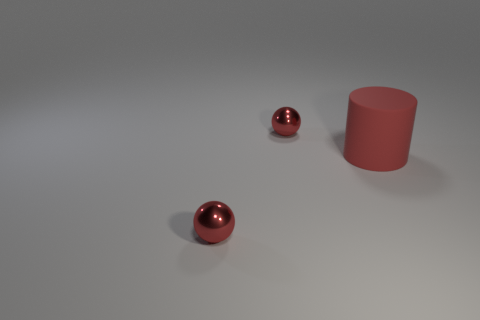How would you interpret the mood or tone conveyed by the scene in this image? The scene conveys a sense of minimalism and tranquility. The clean lines, sparse composition, and muted color palette suggest a calm, almost contemplative mood. The solitary objects imply stillness, with the reflective surface of the spheres adding a subtle dynamic element.  If this image were part of an advertisement, what do you think it could be promoting? If this was an advertisement, the image could be promoting a product or brand associated with simplicity, elegance, or modern design. The clean aesthetic could be representative of a company that values precision and minimalism in their products, such as a high-end electronics manufacturer or a modern furniture designer. 